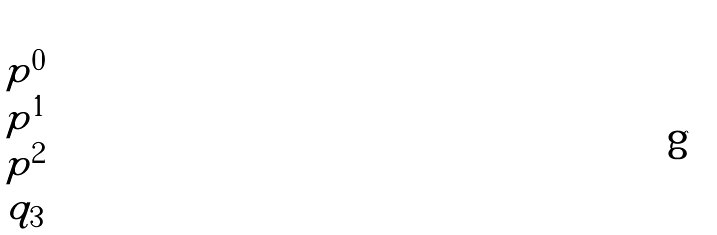<formula> <loc_0><loc_0><loc_500><loc_500>\begin{pmatrix} p ^ { 0 } \\ p ^ { 1 } \\ p ^ { 2 } \\ q _ { 3 } \end{pmatrix}</formula> 